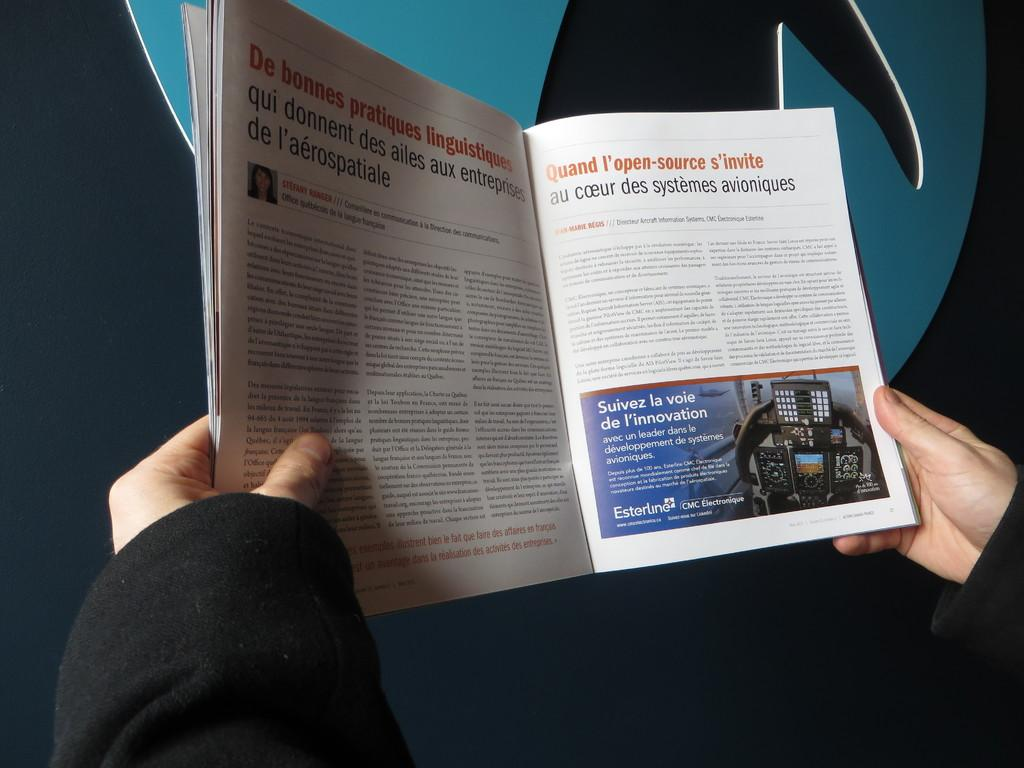Who is present in the image? There is a person in the image. What is the person holding? The person is holding a book. Can you describe the content of the book? There is writing in the book. What can be seen in the background of the image? There is a wall and a banner in the background of the image. What type of advertisement can be seen on the back of the person in the image? There is no advertisement visible on the person's back in the image. 